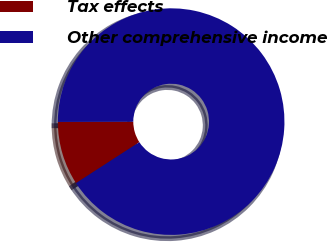Convert chart to OTSL. <chart><loc_0><loc_0><loc_500><loc_500><pie_chart><fcel>Tax effects<fcel>Other comprehensive income<nl><fcel>9.09%<fcel>90.91%<nl></chart> 